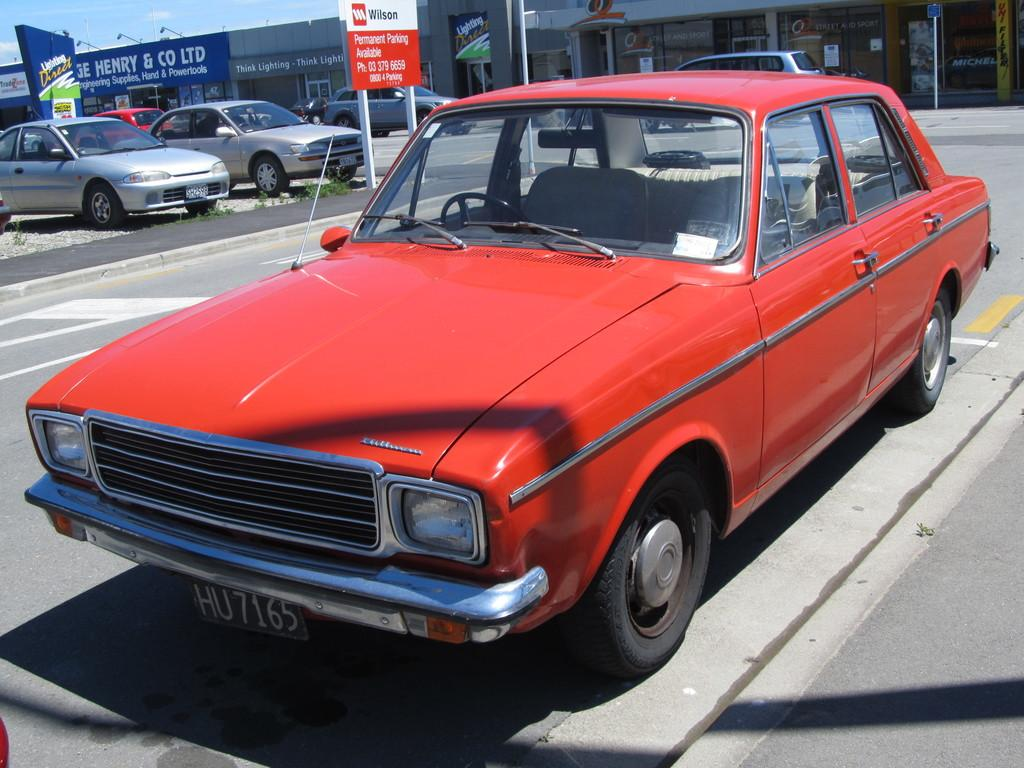What can be seen on the road in the image? There are cars parked on the road in the image. What is visible behind the parked cars? There are stores visible behind the parked cars. What type of signage is present between the parked cars? There are advertisement boards present between the parked cars. How many girls are giving birth in the image? There are no girls or any indication of birth in the image. 